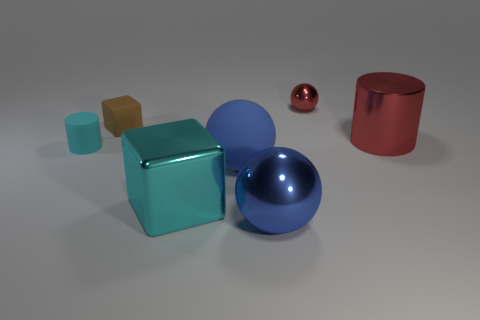There is a red object that is on the right side of the shiny sphere that is to the right of the blue shiny object; what number of metal things are to the left of it?
Provide a succinct answer. 3. What is the thing that is behind the big cylinder and on the right side of the large block made of?
Make the answer very short. Metal. There is a small thing that is behind the large cylinder and in front of the tiny red thing; what color is it?
Provide a short and direct response. Brown. Is there any other thing that has the same color as the rubber block?
Offer a very short reply. No. What is the shape of the tiny rubber thing behind the cylinder that is on the left side of the blue shiny thing that is in front of the large shiny cube?
Offer a terse response. Cube. What is the color of the large thing that is the same shape as the small cyan rubber object?
Make the answer very short. Red. There is a block in front of the red thing that is in front of the tiny brown rubber block; what color is it?
Offer a terse response. Cyan. What size is the blue rubber object that is the same shape as the small shiny thing?
Your answer should be very brief. Large. What number of tiny spheres are made of the same material as the red cylinder?
Your answer should be very brief. 1. There is a cylinder to the right of the tiny brown thing; what number of large blocks are in front of it?
Your response must be concise. 1. 